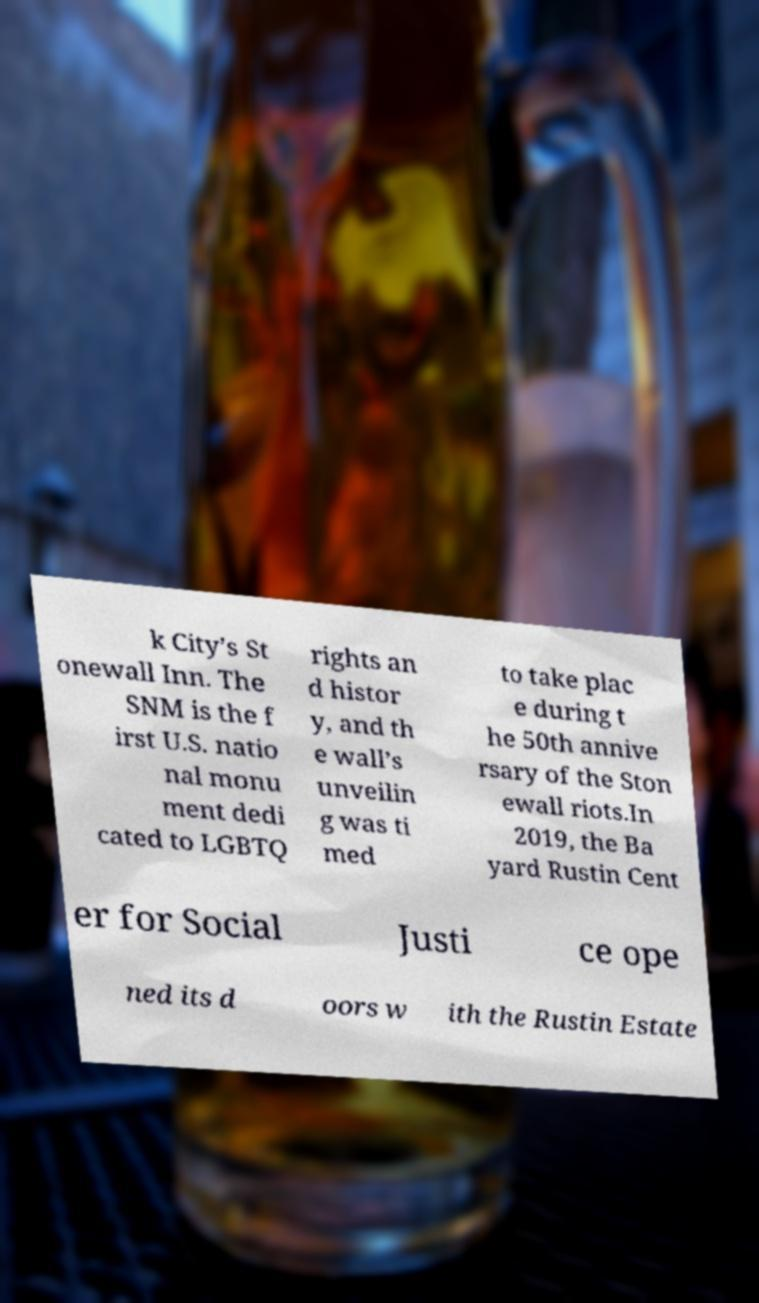Can you read and provide the text displayed in the image?This photo seems to have some interesting text. Can you extract and type it out for me? k City’s St onewall Inn. The SNM is the f irst U.S. natio nal monu ment dedi cated to LGBTQ rights an d histor y, and th e wall’s unveilin g was ti med to take plac e during t he 50th annive rsary of the Ston ewall riots.In 2019, the Ba yard Rustin Cent er for Social Justi ce ope ned its d oors w ith the Rustin Estate 